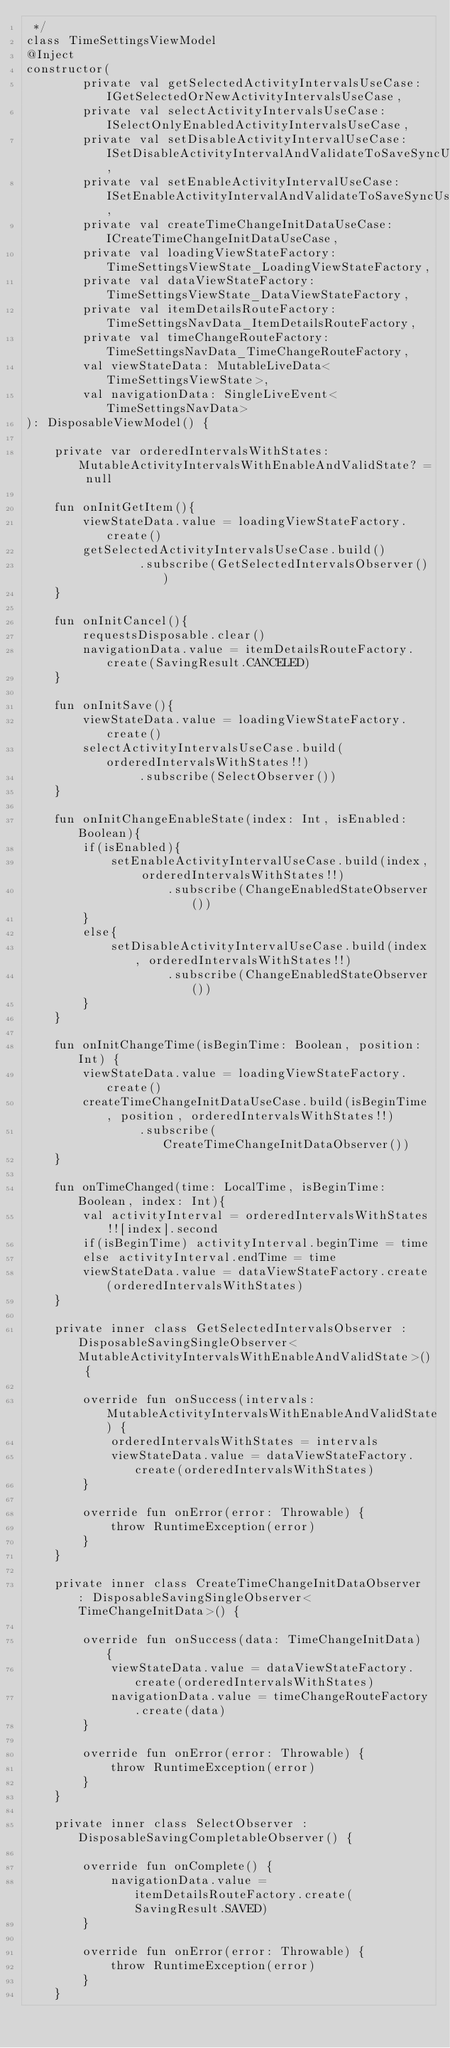<code> <loc_0><loc_0><loc_500><loc_500><_Kotlin_> */
class TimeSettingsViewModel
@Inject
constructor(
        private val getSelectedActivityIntervalsUseCase: IGetSelectedOrNewActivityIntervalsUseCase,
        private val selectActivityIntervalsUseCase: ISelectOnlyEnabledActivityIntervalsUseCase,
        private val setDisableActivityIntervalUseCase: ISetDisableActivityIntervalAndValidateToSaveSyncUseCase,
        private val setEnableActivityIntervalUseCase: ISetEnableActivityIntervalAndValidateToSaveSyncUseCase,
        private val createTimeChangeInitDataUseCase: ICreateTimeChangeInitDataUseCase,
        private val loadingViewStateFactory: TimeSettingsViewState_LoadingViewStateFactory,
        private val dataViewStateFactory: TimeSettingsViewState_DataViewStateFactory,
        private val itemDetailsRouteFactory: TimeSettingsNavData_ItemDetailsRouteFactory,
        private val timeChangeRouteFactory: TimeSettingsNavData_TimeChangeRouteFactory,
        val viewStateData: MutableLiveData<TimeSettingsViewState>,
        val navigationData: SingleLiveEvent<TimeSettingsNavData>
): DisposableViewModel() {

    private var orderedIntervalsWithStates: MutableActivityIntervalsWithEnableAndValidState? = null

    fun onInitGetItem(){
        viewStateData.value = loadingViewStateFactory.create()
        getSelectedActivityIntervalsUseCase.build()
                .subscribe(GetSelectedIntervalsObserver())
    }

    fun onInitCancel(){
        requestsDisposable.clear()
        navigationData.value = itemDetailsRouteFactory.create(SavingResult.CANCELED)
    }

    fun onInitSave(){
        viewStateData.value = loadingViewStateFactory.create()
        selectActivityIntervalsUseCase.build(orderedIntervalsWithStates!!)
                .subscribe(SelectObserver())
    }

    fun onInitChangeEnableState(index: Int, isEnabled: Boolean){
        if(isEnabled){
            setEnableActivityIntervalUseCase.build(index, orderedIntervalsWithStates!!)
                    .subscribe(ChangeEnabledStateObserver())
        }
        else{
            setDisableActivityIntervalUseCase.build(index, orderedIntervalsWithStates!!)
                    .subscribe(ChangeEnabledStateObserver())
        }
    }

    fun onInitChangeTime(isBeginTime: Boolean, position: Int) {
        viewStateData.value = loadingViewStateFactory.create()
        createTimeChangeInitDataUseCase.build(isBeginTime, position, orderedIntervalsWithStates!!)
                .subscribe(CreateTimeChangeInitDataObserver())
    }

    fun onTimeChanged(time: LocalTime, isBeginTime: Boolean, index: Int){
        val activityInterval = orderedIntervalsWithStates!![index].second
        if(isBeginTime) activityInterval.beginTime = time
        else activityInterval.endTime = time
        viewStateData.value = dataViewStateFactory.create(orderedIntervalsWithStates)
    }

    private inner class GetSelectedIntervalsObserver : DisposableSavingSingleObserver<MutableActivityIntervalsWithEnableAndValidState>() {

        override fun onSuccess(intervals: MutableActivityIntervalsWithEnableAndValidState) {
            orderedIntervalsWithStates = intervals
            viewStateData.value = dataViewStateFactory.create(orderedIntervalsWithStates)
        }

        override fun onError(error: Throwable) {
            throw RuntimeException(error)
        }
    }

    private inner class CreateTimeChangeInitDataObserver : DisposableSavingSingleObserver<TimeChangeInitData>() {

        override fun onSuccess(data: TimeChangeInitData) {
            viewStateData.value = dataViewStateFactory.create(orderedIntervalsWithStates)
            navigationData.value = timeChangeRouteFactory.create(data)
        }

        override fun onError(error: Throwable) {
            throw RuntimeException(error)
        }
    }

    private inner class SelectObserver : DisposableSavingCompletableObserver() {

        override fun onComplete() {
            navigationData.value = itemDetailsRouteFactory.create(SavingResult.SAVED)
        }

        override fun onError(error: Throwable) {
            throw RuntimeException(error)
        }
    }
</code> 